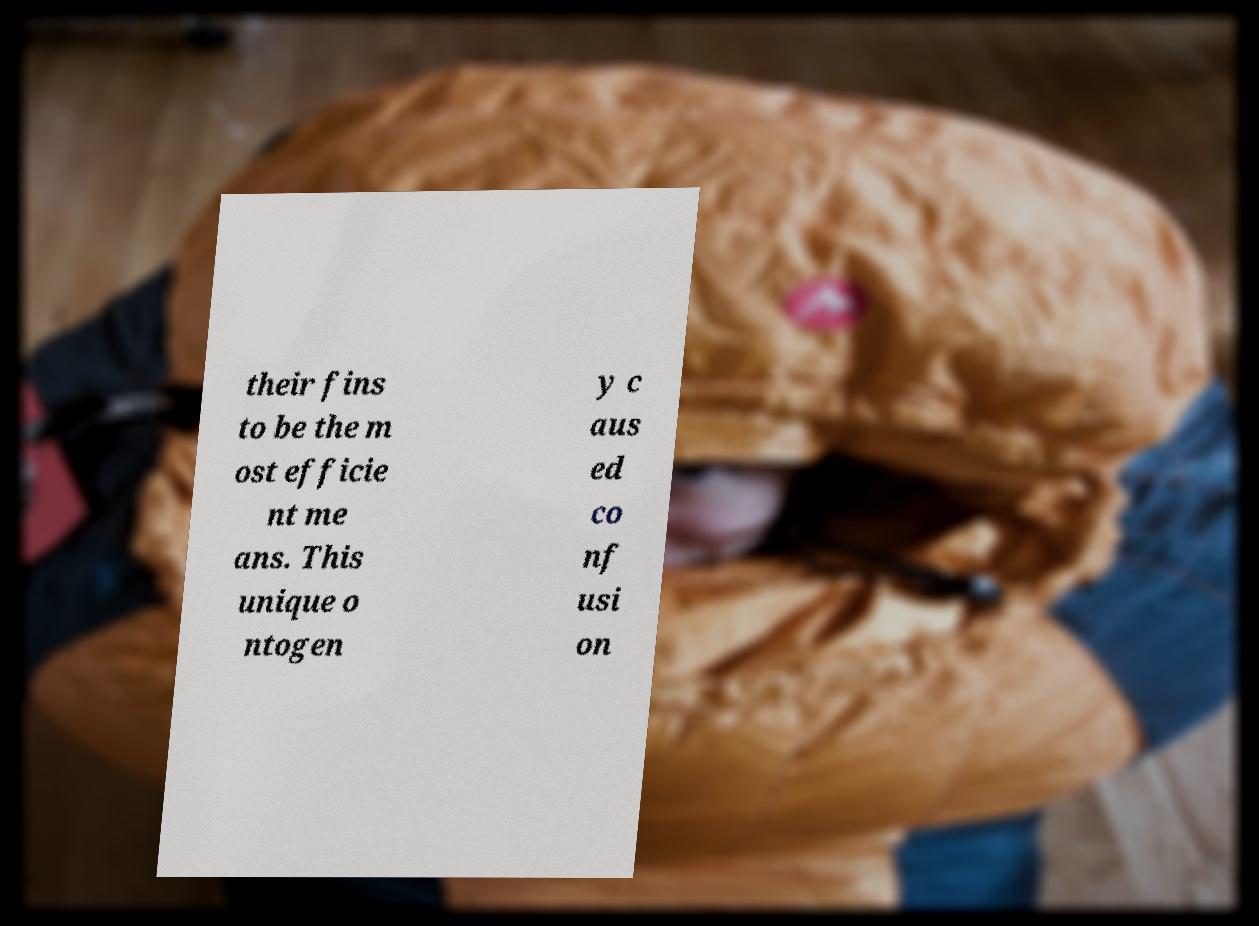Can you read and provide the text displayed in the image?This photo seems to have some interesting text. Can you extract and type it out for me? their fins to be the m ost efficie nt me ans. This unique o ntogen y c aus ed co nf usi on 